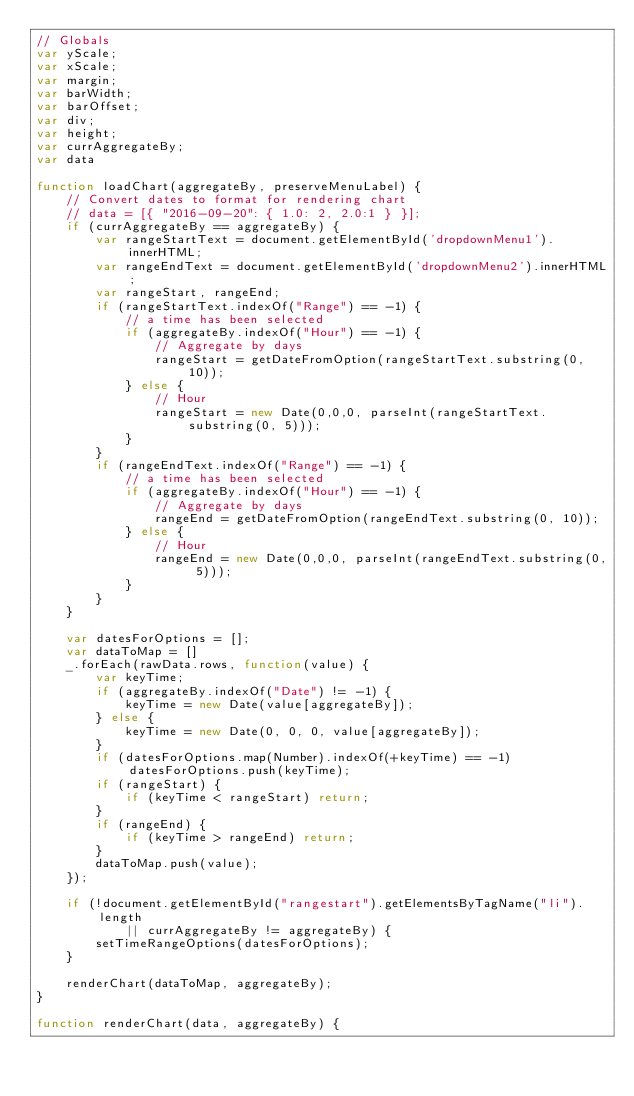Convert code to text. <code><loc_0><loc_0><loc_500><loc_500><_JavaScript_>// Globals
var yScale;
var xScale;
var margin;
var barWidth;
var barOffset;
var div;
var height;
var currAggregateBy;
var data

function loadChart(aggregateBy, preserveMenuLabel) {
    // Convert dates to format for rendering chart
    // data = [{ "2016-09-20": { 1.0: 2, 2.0:1 } }];
    if (currAggregateBy == aggregateBy) {
        var rangeStartText = document.getElementById('dropdownMenu1').innerHTML;
        var rangeEndText = document.getElementById('dropdownMenu2').innerHTML;
        var rangeStart, rangeEnd;
        if (rangeStartText.indexOf("Range") == -1) { 
            // a time has been selected
            if (aggregateBy.indexOf("Hour") == -1) {
                // Aggregate by days
                rangeStart = getDateFromOption(rangeStartText.substring(0, 10));
            } else {
                // Hour
                rangeStart = new Date(0,0,0, parseInt(rangeStartText.substring(0, 5)));
            }
        }
        if (rangeEndText.indexOf("Range") == -1) { 
            // a time has been selected
            if (aggregateBy.indexOf("Hour") == -1) {
                // Aggregate by days
                rangeEnd = getDateFromOption(rangeEndText.substring(0, 10));
            } else {
                // Hour
                rangeEnd = new Date(0,0,0, parseInt(rangeEndText.substring(0, 5)));
            }
        }
    }
    
    var datesForOptions = [];
    var dataToMap = []
    _.forEach(rawData.rows, function(value) {
        var keyTime;
        if (aggregateBy.indexOf("Date") != -1) {
            keyTime = new Date(value[aggregateBy]);
        } else {
            keyTime = new Date(0, 0, 0, value[aggregateBy]);
        }
        if (datesForOptions.map(Number).indexOf(+keyTime) == -1) datesForOptions.push(keyTime);
        if (rangeStart) {
            if (keyTime < rangeStart) return;
        }
        if (rangeEnd) {
            if (keyTime > rangeEnd) return;
        }
        dataToMap.push(value);
    });

    if (!document.getElementById("rangestart").getElementsByTagName("li").length
            || currAggregateBy != aggregateBy) {
        setTimeRangeOptions(datesForOptions);
    }

    renderChart(dataToMap, aggregateBy);
}

function renderChart(data, aggregateBy) {</code> 